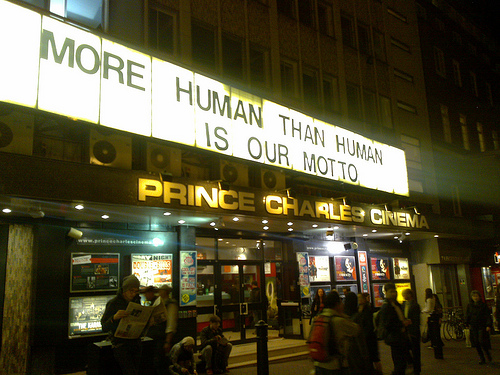<image>
Can you confirm if the backpack is in front of the newspaper? Yes. The backpack is positioned in front of the newspaper, appearing closer to the camera viewpoint. 